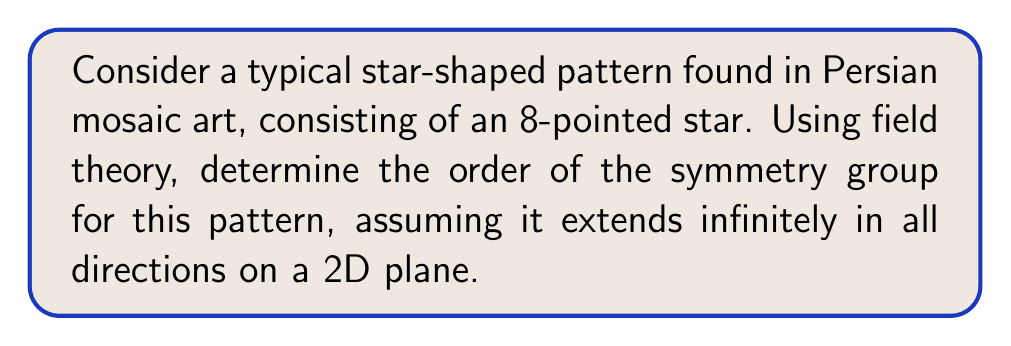Help me with this question. Let's approach this step-by-step using field theory concepts:

1) First, we need to identify the symmetries of the pattern:
   - Rotational symmetry: The pattern has 8-fold rotational symmetry (rotations by multiples of 45°)
   - Reflectional symmetry: There are 8 lines of reflection (4 through the points and 4 between the points)
   - Translational symmetry: The pattern repeats infinitely in all directions

2) In field theory, we can represent these symmetries using group theory. The symmetry group of this pattern is a wallpaper group.

3) The specific wallpaper group for this pattern is p4m, which is one of the 17 possible wallpaper groups.

4) The p4m group is generated by:
   - Rotations of order 4 (90° rotations)
   - Reflections
   - Translations

5) To calculate the order of this group, we need to consider that it's an infinite group due to the translations. However, we can look at the point group, which is the group of symmetries that leave a point fixed.

6) The point group for p4m is the dihedral group $D_4$, which has order 8.

7) The order of $D_4$ can be calculated as follows:
   $$|D_4| = 2n = 2(4) = 8$$
   where n is the number of rotational symmetries.

8) This means there are 8 symmetry operations that leave a point fixed: 4 rotations (0°, 90°, 180°, 270°) and 4 reflections.

9) The full symmetry group is infinite due to translations, but it's characterized by this point group of order 8.
Answer: $\infty$ (infinite order group with point group of order 8) 